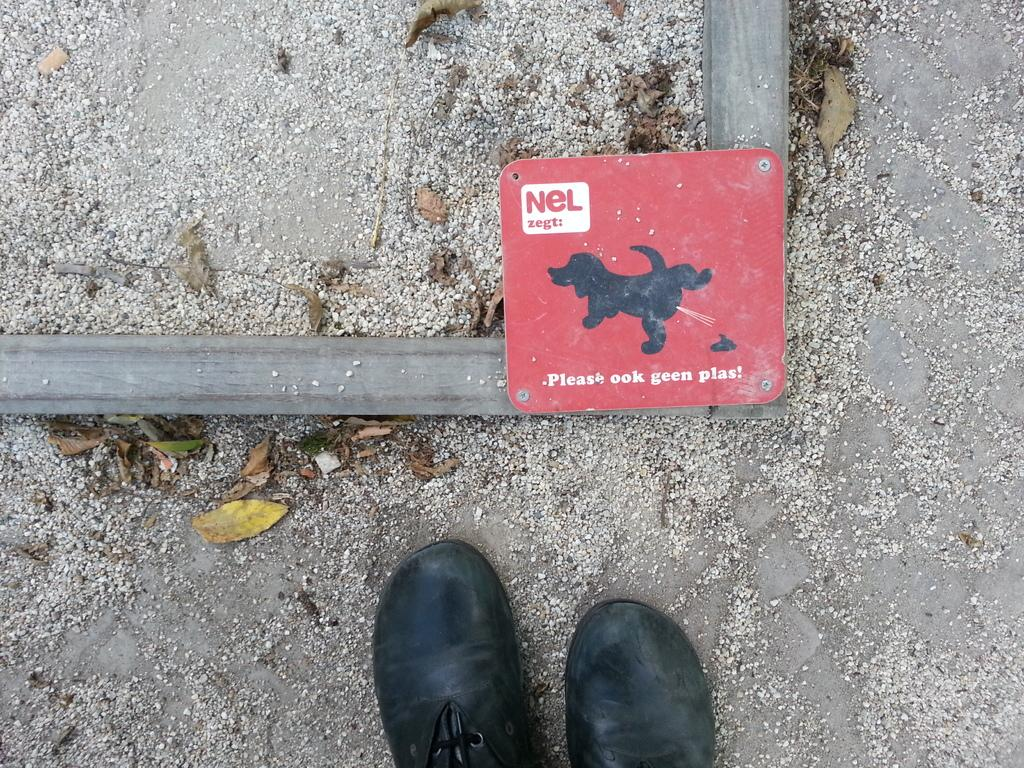What type of natural material is present in the image? There are stones in the image. What type of plant material is present in the image? There are shredded leaves in the image. What type of personal item is present in the image? There are shoes in the image. What type of informational sign is present in the image? There is an information board in the image. What type of playground equipment can be seen in the image? There is no playground equipment present in the image. Is there any indication that someone is driving in the image? There is no indication of driving or any vehicle in the image. 